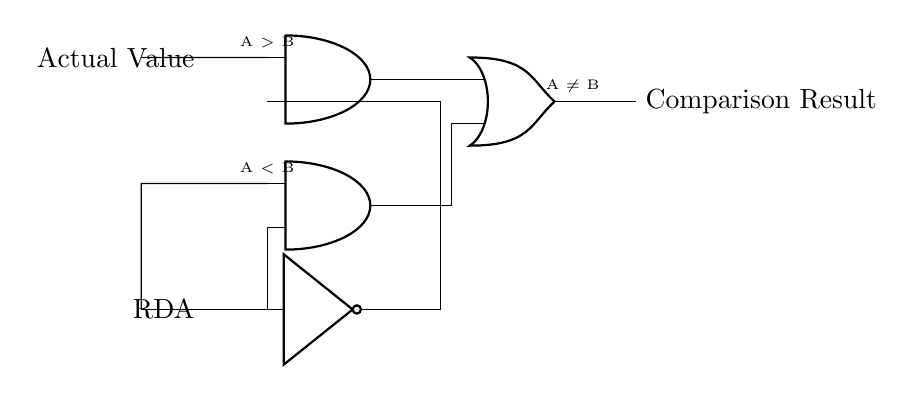What is the output of the circuit? The output of the circuit is determined by the logic gates’ conditions. Here, it's labeled as "Comparison Result," meaning it results from evaluating whether the actual value is greater than, less than, or not equal to the RDA.
Answer: Comparison Result What components are at the input? The input consists of two nodes: one labeled "Actual Value" and the other "RDA" for the Recommended Daily Allowance. The Actual Value connects to the AND gates, while the RDA connects via a NOT gate.
Answer: Actual Value and RDA How many logic gates are used in this circuit? The circuit contains three logic gates: two AND gates and one OR gate. This can be counted directly from the diagram, where each gate is represented distinctly.
Answer: Three What type of logic gates are used in the circuit? The circuit uses AND and OR gates, as indicated by the symbols in the diagram. There is also a NOT gate used for inverting the RDA input, which is important for the comparison logic.
Answer: AND, OR, and NOT gates What does A greater than B signify in this circuit? The condition A greater than B refers to the comparison of the actual nutritional value (A) against the recommended daily allowance (B), signifying that the actual value exceeds the recommendation. The relationship is processed by the logic gates to produce a comparison output.
Answer: A greater than B How does the NOT gate affect the RDA input? The NOT gate inverses the RDA value before it feeds into the AND gate, which means that if the RDA is true, the NOT gate will output false. This inversion is crucial for determining comparisons correctly, allowing evaluation of values accordingly.
Answer: It inverts the RDA input 